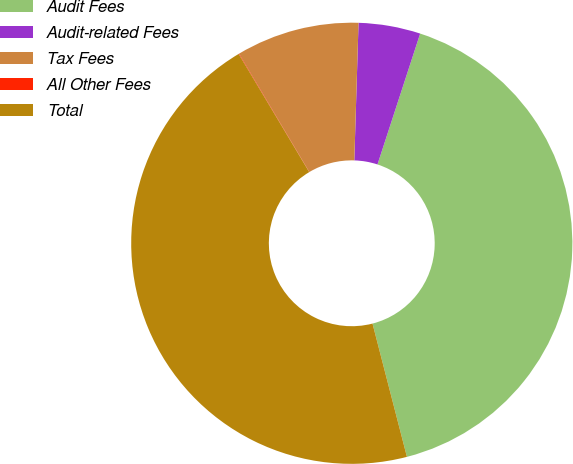Convert chart. <chart><loc_0><loc_0><loc_500><loc_500><pie_chart><fcel>Audit Fees<fcel>Audit-related Fees<fcel>Tax Fees<fcel>All Other Fees<fcel>Total<nl><fcel>40.96%<fcel>4.53%<fcel>9.02%<fcel>0.04%<fcel>45.45%<nl></chart> 